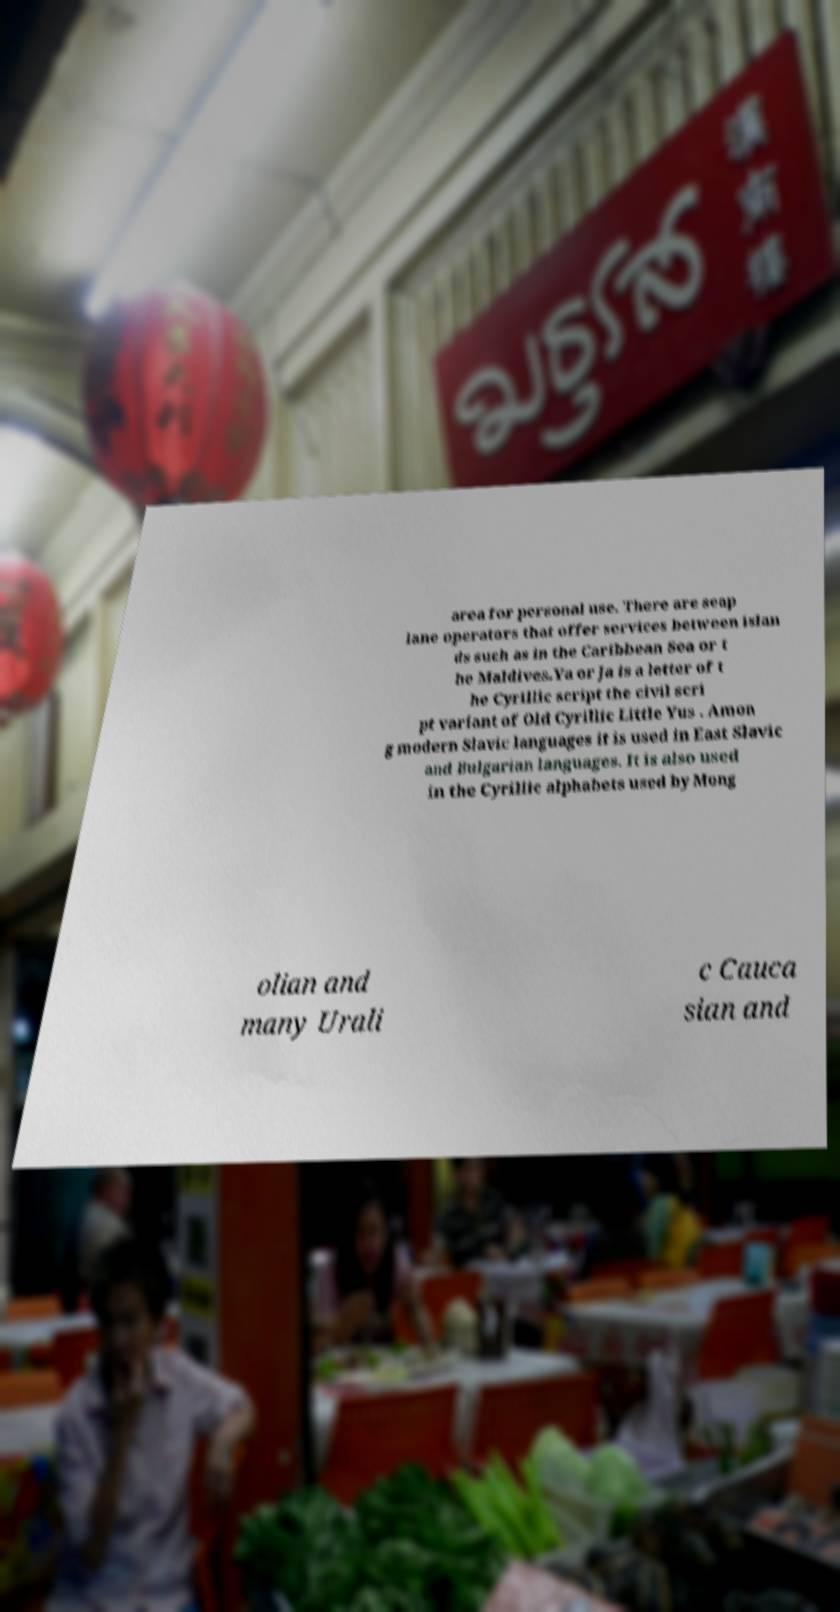Could you extract and type out the text from this image? area for personal use. There are seap lane operators that offer services between islan ds such as in the Caribbean Sea or t he Maldives.Ya or Ja is a letter of t he Cyrillic script the civil scri pt variant of Old Cyrillic Little Yus . Amon g modern Slavic languages it is used in East Slavic and Bulgarian languages. It is also used in the Cyrillic alphabets used by Mong olian and many Urali c Cauca sian and 